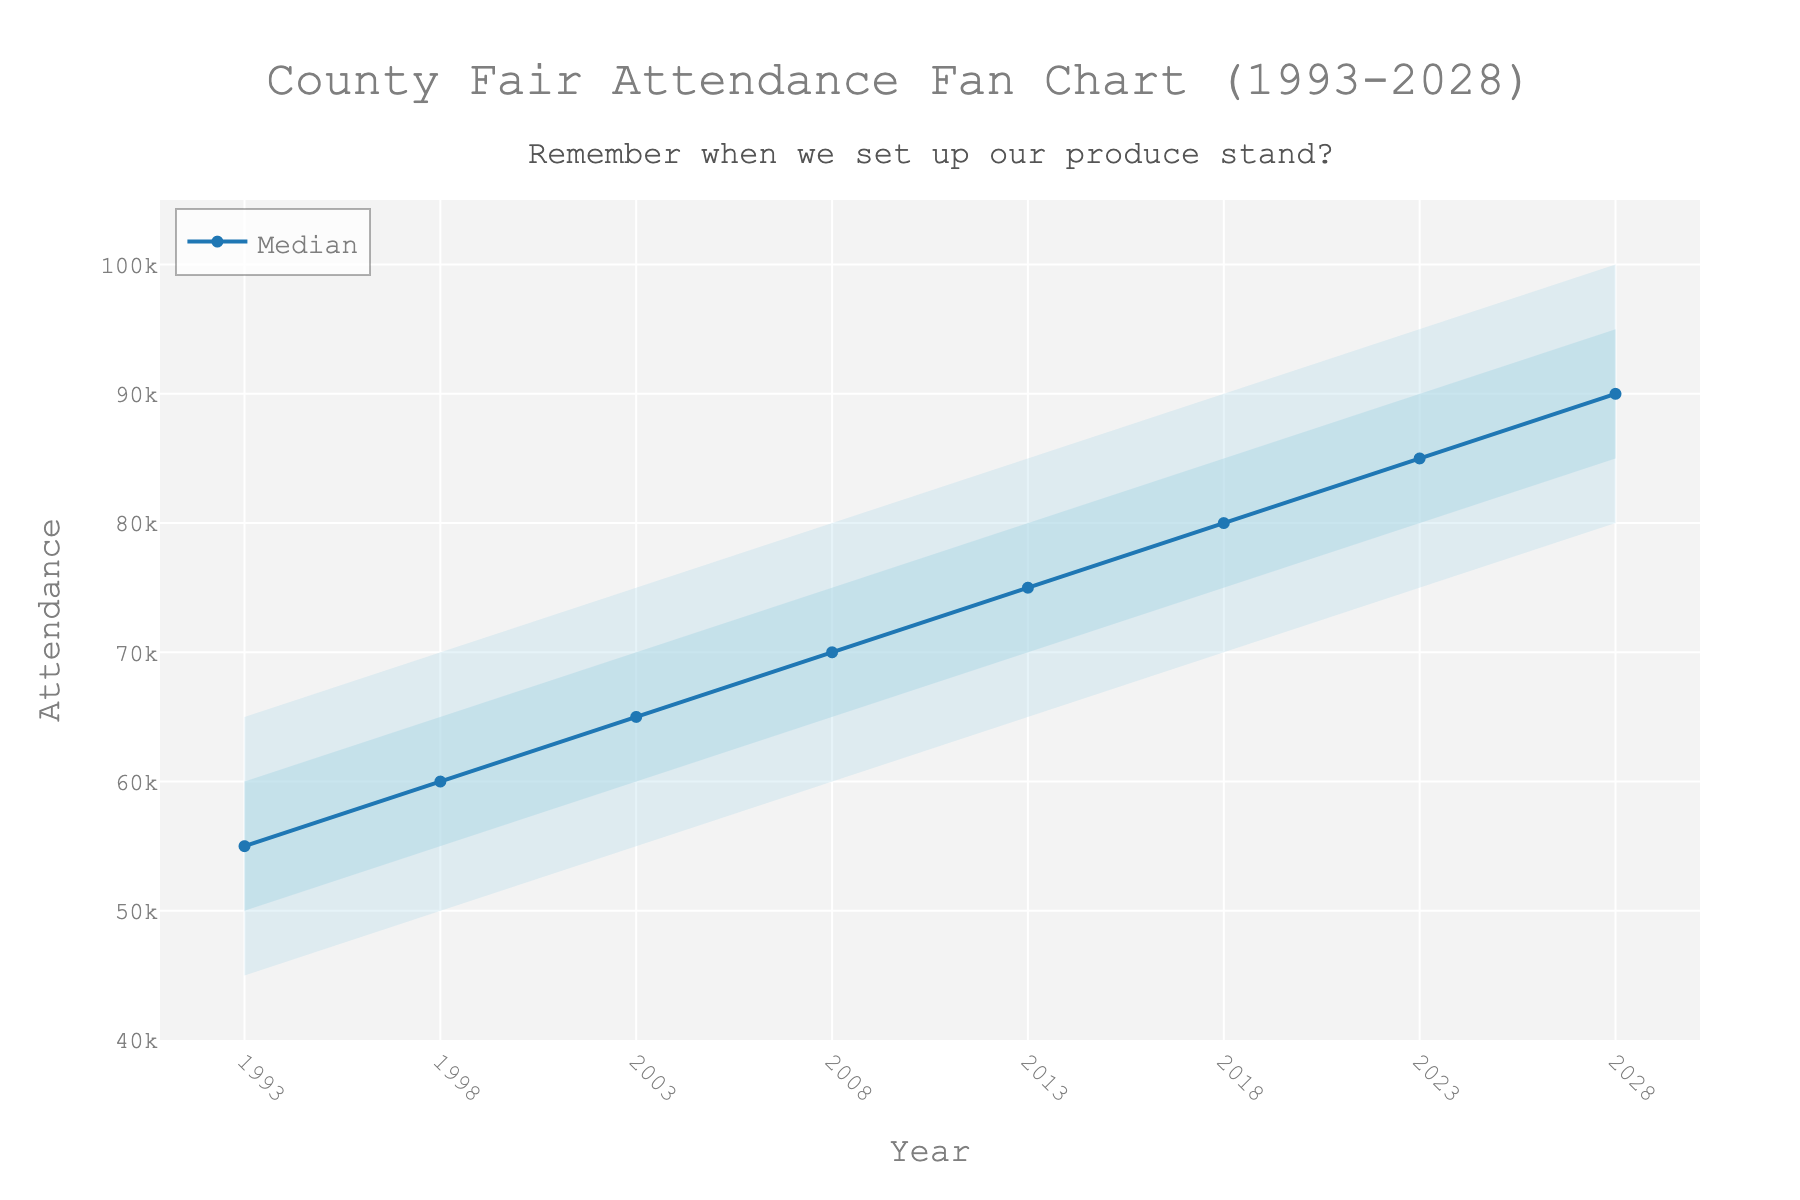What is the title of the fan chart? The title is shown at the top of the chart and reads, "County Fair Attendance Fan Chart (1993-2028)."
Answer: County Fair Attendance Fan Chart (1993-2028) What is the range of years displayed on the x-axis? The x-axis shows the years starting from 1993 to 2028.
Answer: 1993 to 2028 What is the median attendance value for the year 2003? The median value for 2003 can be found by looking at the "Mid" line corresponding to the year 2003. The value is 65,000.
Answer: 65,000 How does the median attendance value in 2018 compare to that in 1993? By comparing the "Mid" values for 2018 and 1993, we see the median value in 2018 is 80,000, while in 1993 it is 55,000. So, the median attendance increased.
Answer: Increased What's the maximum forecasted attendance for the year 2028? This value corresponds to the "High" line for the year 2028, which is 100,000.
Answer: 100,000 What is the attendance range for the year 2023? The range is from the "Low" value to the "High" value for the year 2023. The values are 75,000 to 95,000.
Answer: 75,000 to 95,000 What trend can be observed in the attendance figures from 1993 to 2028 based on the median values? Observing the "Mid" line from 1993 to 2028, the median attendance shows a consistent increasing trend.
Answer: Increasing trend What are the predicted attendance values for the year 2023? Viewing from the year 2023, the values span from 75,000 (Low) to 95,000 (High) with a median value of 85,000.
Answer: 75,000 to 95,000 with a median of 85,000 Between what values does the "Low-Mid" to "Mid-High" interval fall in the year 2008? This interval for 2008 spans from the "Low-Mid" value of 65,000 to the "Mid-High" value of 75,000.
Answer: 65,000 to 75,000 What does the color shading represent in the fan chart? The different shades of blue represent various confidence intervals of attendance predictions, with darker shades indicating narrower intervals.
Answer: Confidence intervals 